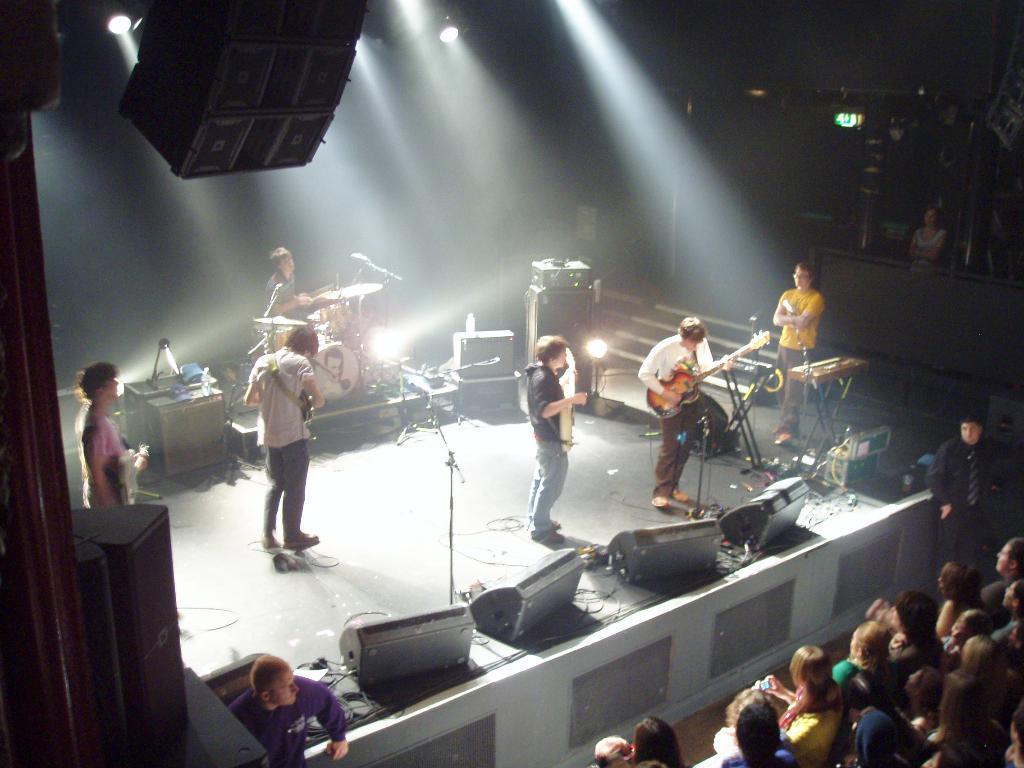Could you give a brief overview of what you see in this image? In this image I can see number of people were few of them are standing and few are sitting. Here on this stage I can see few people are holding guitars. 